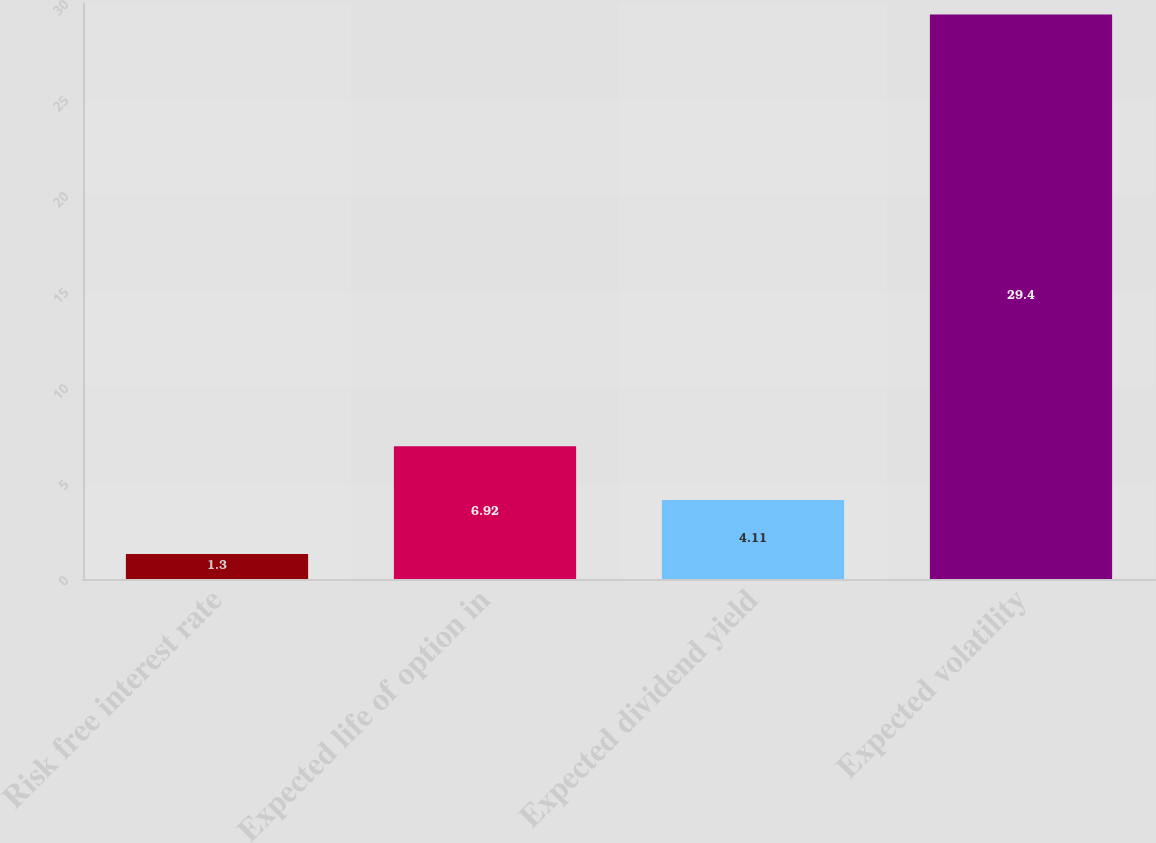<chart> <loc_0><loc_0><loc_500><loc_500><bar_chart><fcel>Risk free interest rate<fcel>Expected life of option in<fcel>Expected dividend yield<fcel>Expected volatility<nl><fcel>1.3<fcel>6.92<fcel>4.11<fcel>29.4<nl></chart> 